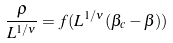Convert formula to latex. <formula><loc_0><loc_0><loc_500><loc_500>\frac { \rho } { L ^ { 1 / \nu } } = f ( L ^ { 1 / \nu } ( \beta _ { c } - \beta ) )</formula> 